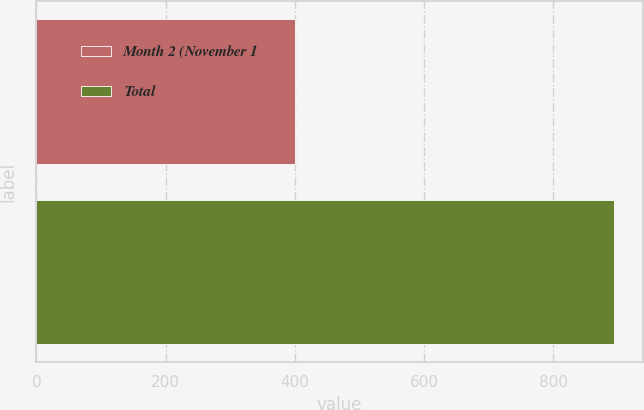Convert chart to OTSL. <chart><loc_0><loc_0><loc_500><loc_500><bar_chart><fcel>Month 2 (November 1<fcel>Total<nl><fcel>400<fcel>894<nl></chart> 